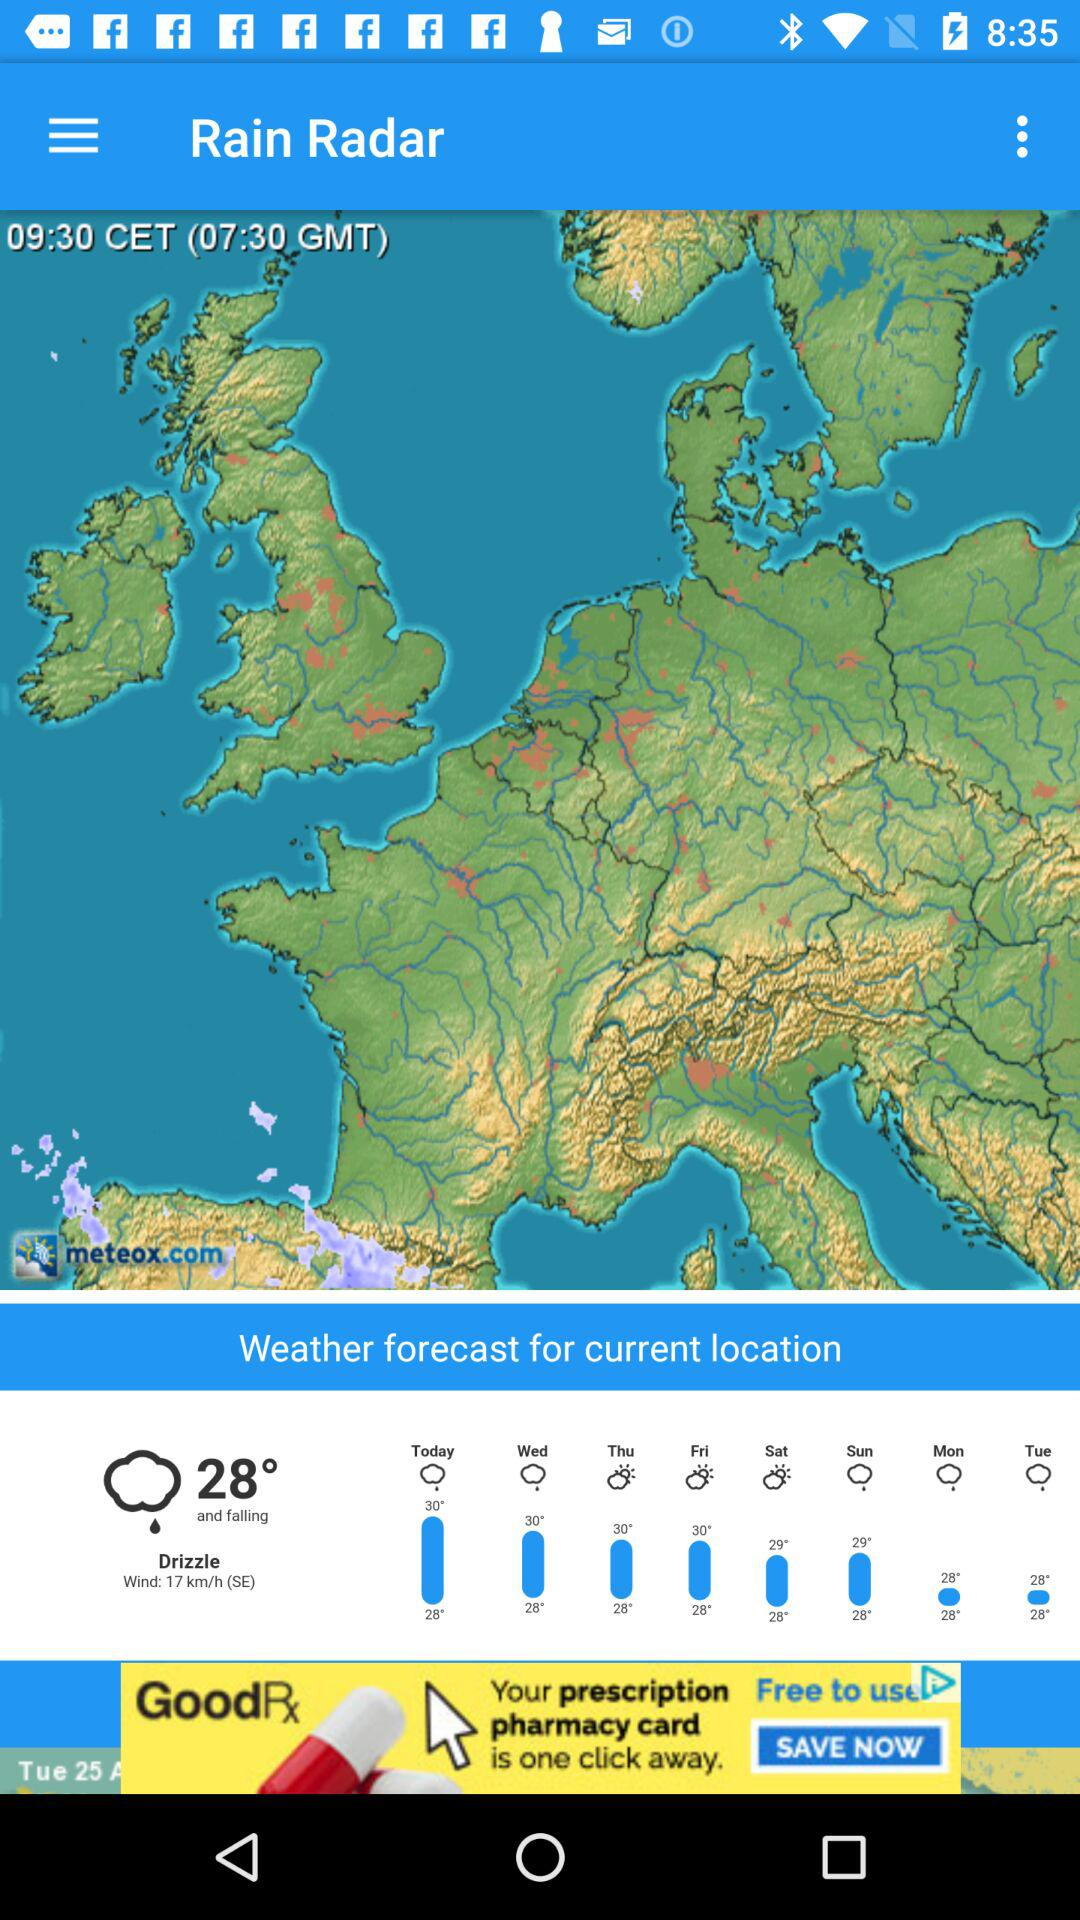What is the given time? The given time is 09:30 CET and 07:30 GMT. 